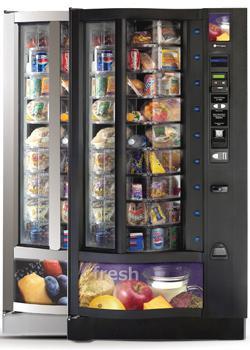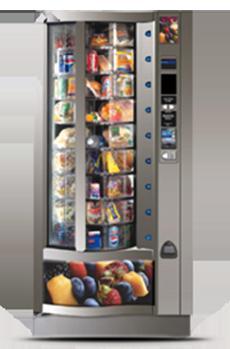The first image is the image on the left, the second image is the image on the right. Given the left and right images, does the statement "Three or more vending machines sell fresh food." hold true? Answer yes or no. Yes. The first image is the image on the left, the second image is the image on the right. For the images shown, is this caption "In one of the images, at least three vending machines are lined up together." true? Answer yes or no. No. 